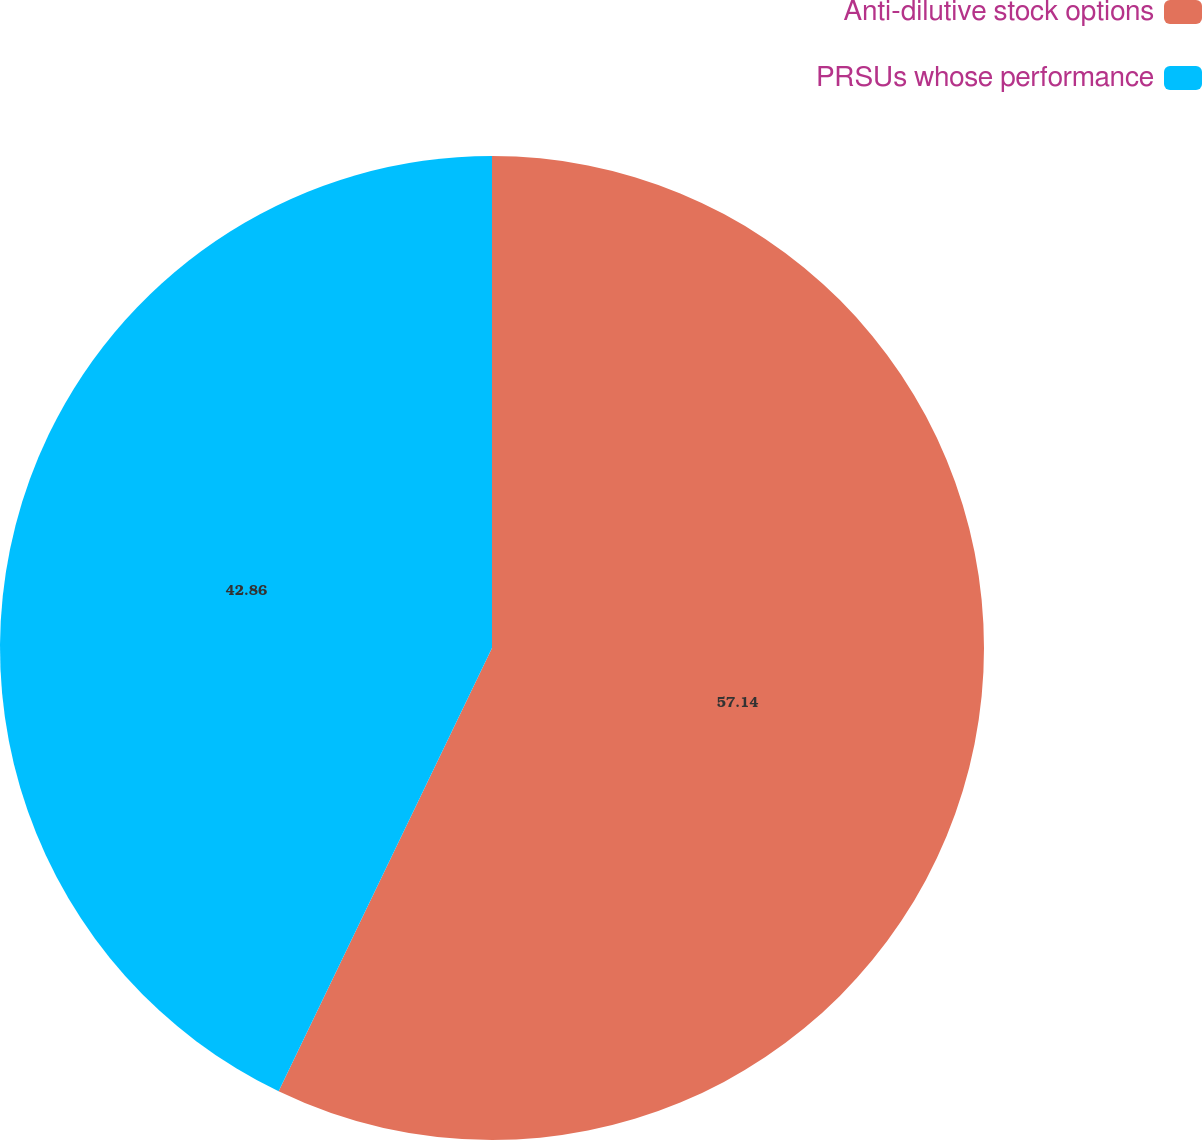Convert chart. <chart><loc_0><loc_0><loc_500><loc_500><pie_chart><fcel>Anti-dilutive stock options<fcel>PRSUs whose performance<nl><fcel>57.14%<fcel>42.86%<nl></chart> 